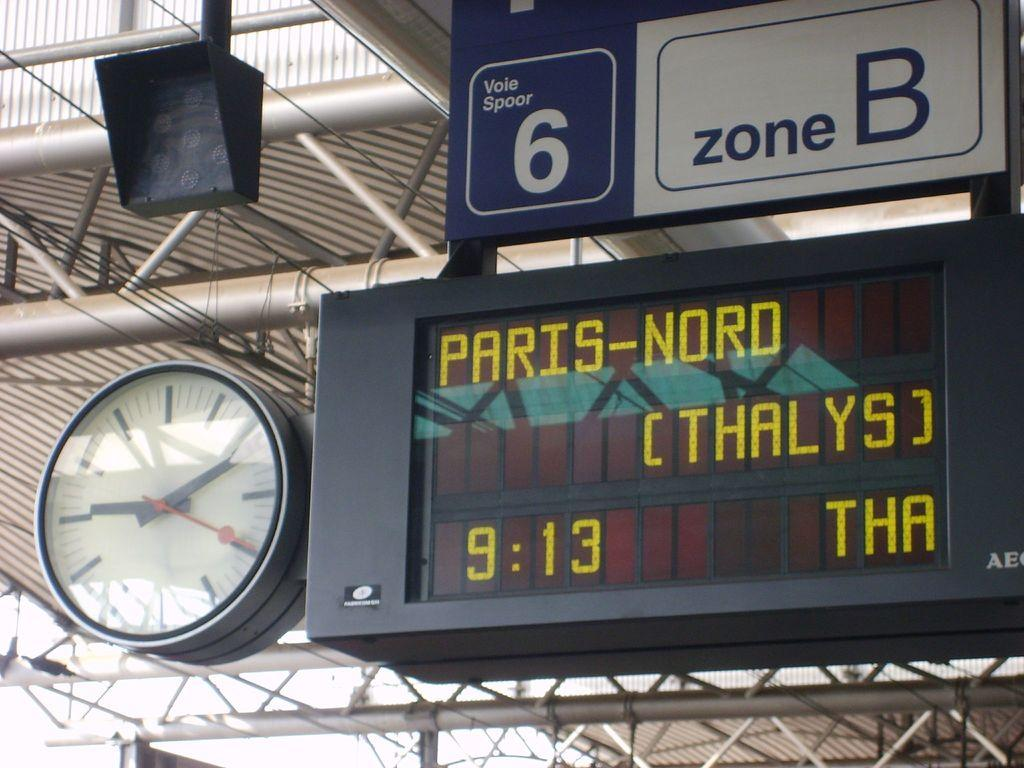Provide a one-sentence caption for the provided image. The section 6 zone B arrival board at a train station is displaying the information for Paris-Nord. 